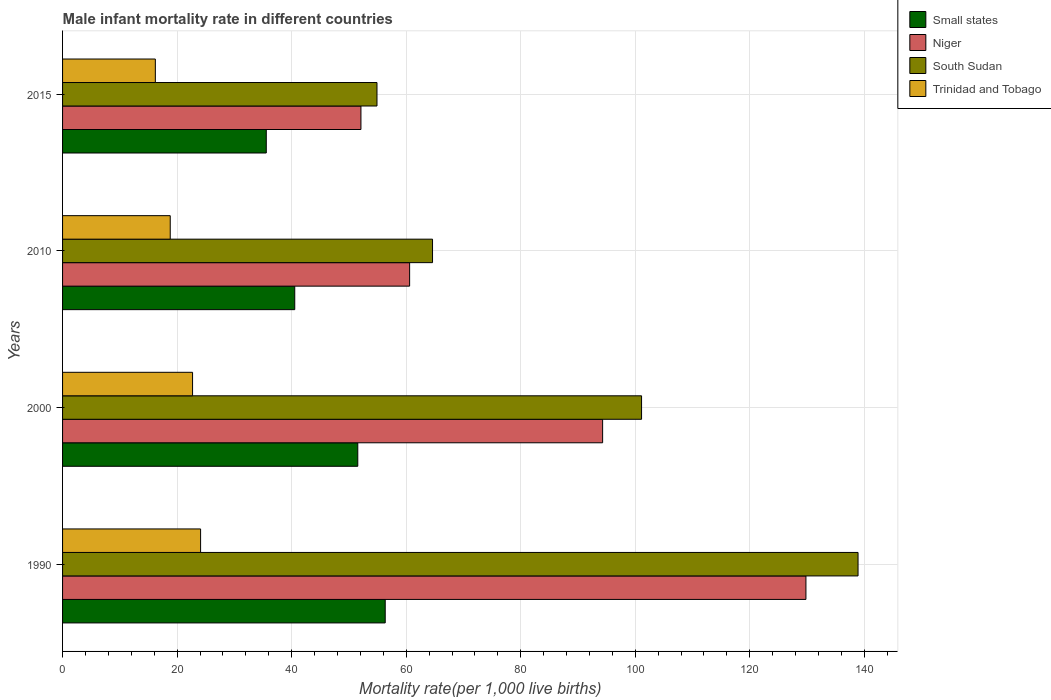How many different coloured bars are there?
Ensure brevity in your answer.  4. Are the number of bars on each tick of the Y-axis equal?
Provide a succinct answer. Yes. How many bars are there on the 4th tick from the top?
Your answer should be compact. 4. How many bars are there on the 2nd tick from the bottom?
Your response must be concise. 4. What is the label of the 2nd group of bars from the top?
Keep it short and to the point. 2010. What is the male infant mortality rate in Trinidad and Tobago in 2000?
Provide a succinct answer. 22.7. Across all years, what is the maximum male infant mortality rate in South Sudan?
Provide a succinct answer. 138.9. Across all years, what is the minimum male infant mortality rate in Small states?
Ensure brevity in your answer.  35.57. In which year was the male infant mortality rate in Niger minimum?
Provide a succinct answer. 2015. What is the total male infant mortality rate in Niger in the graph?
Offer a very short reply. 336.8. What is the difference between the male infant mortality rate in Small states in 1990 and that in 2000?
Your answer should be compact. 4.79. What is the difference between the male infant mortality rate in Small states in 2010 and the male infant mortality rate in Niger in 2015?
Provide a succinct answer. -11.56. What is the average male infant mortality rate in Trinidad and Tobago per year?
Your answer should be compact. 20.45. In the year 1990, what is the difference between the male infant mortality rate in Trinidad and Tobago and male infant mortality rate in Small states?
Offer a terse response. -32.24. What is the ratio of the male infant mortality rate in Trinidad and Tobago in 2000 to that in 2015?
Offer a very short reply. 1.4. What is the difference between the highest and the second highest male infant mortality rate in South Sudan?
Provide a succinct answer. 37.8. What is the difference between the highest and the lowest male infant mortality rate in Small states?
Give a very brief answer. 20.77. In how many years, is the male infant mortality rate in Niger greater than the average male infant mortality rate in Niger taken over all years?
Your answer should be very brief. 2. Is it the case that in every year, the sum of the male infant mortality rate in Small states and male infant mortality rate in Niger is greater than the sum of male infant mortality rate in Trinidad and Tobago and male infant mortality rate in South Sudan?
Provide a succinct answer. No. What does the 3rd bar from the top in 2010 represents?
Make the answer very short. Niger. What does the 1st bar from the bottom in 2015 represents?
Your response must be concise. Small states. Is it the case that in every year, the sum of the male infant mortality rate in Small states and male infant mortality rate in South Sudan is greater than the male infant mortality rate in Trinidad and Tobago?
Ensure brevity in your answer.  Yes. What is the difference between two consecutive major ticks on the X-axis?
Ensure brevity in your answer.  20. Are the values on the major ticks of X-axis written in scientific E-notation?
Provide a succinct answer. No. Does the graph contain any zero values?
Your answer should be very brief. No. How many legend labels are there?
Offer a terse response. 4. How are the legend labels stacked?
Ensure brevity in your answer.  Vertical. What is the title of the graph?
Ensure brevity in your answer.  Male infant mortality rate in different countries. Does "Liechtenstein" appear as one of the legend labels in the graph?
Ensure brevity in your answer.  No. What is the label or title of the X-axis?
Make the answer very short. Mortality rate(per 1,0 live births). What is the label or title of the Y-axis?
Provide a succinct answer. Years. What is the Mortality rate(per 1,000 live births) of Small states in 1990?
Provide a succinct answer. 56.34. What is the Mortality rate(per 1,000 live births) of Niger in 1990?
Provide a succinct answer. 129.8. What is the Mortality rate(per 1,000 live births) of South Sudan in 1990?
Provide a succinct answer. 138.9. What is the Mortality rate(per 1,000 live births) of Trinidad and Tobago in 1990?
Offer a very short reply. 24.1. What is the Mortality rate(per 1,000 live births) of Small states in 2000?
Keep it short and to the point. 51.55. What is the Mortality rate(per 1,000 live births) in Niger in 2000?
Keep it short and to the point. 94.3. What is the Mortality rate(per 1,000 live births) in South Sudan in 2000?
Keep it short and to the point. 101.1. What is the Mortality rate(per 1,000 live births) in Trinidad and Tobago in 2000?
Your answer should be very brief. 22.7. What is the Mortality rate(per 1,000 live births) of Small states in 2010?
Your answer should be compact. 40.54. What is the Mortality rate(per 1,000 live births) of Niger in 2010?
Your answer should be very brief. 60.6. What is the Mortality rate(per 1,000 live births) in South Sudan in 2010?
Offer a very short reply. 64.6. What is the Mortality rate(per 1,000 live births) of Trinidad and Tobago in 2010?
Your answer should be compact. 18.8. What is the Mortality rate(per 1,000 live births) of Small states in 2015?
Make the answer very short. 35.57. What is the Mortality rate(per 1,000 live births) of Niger in 2015?
Offer a terse response. 52.1. What is the Mortality rate(per 1,000 live births) of South Sudan in 2015?
Your response must be concise. 54.9. What is the Mortality rate(per 1,000 live births) of Trinidad and Tobago in 2015?
Provide a short and direct response. 16.2. Across all years, what is the maximum Mortality rate(per 1,000 live births) in Small states?
Provide a short and direct response. 56.34. Across all years, what is the maximum Mortality rate(per 1,000 live births) of Niger?
Your answer should be compact. 129.8. Across all years, what is the maximum Mortality rate(per 1,000 live births) in South Sudan?
Your answer should be compact. 138.9. Across all years, what is the maximum Mortality rate(per 1,000 live births) in Trinidad and Tobago?
Ensure brevity in your answer.  24.1. Across all years, what is the minimum Mortality rate(per 1,000 live births) of Small states?
Your response must be concise. 35.57. Across all years, what is the minimum Mortality rate(per 1,000 live births) of Niger?
Ensure brevity in your answer.  52.1. Across all years, what is the minimum Mortality rate(per 1,000 live births) in South Sudan?
Provide a succinct answer. 54.9. What is the total Mortality rate(per 1,000 live births) in Small states in the graph?
Offer a very short reply. 184. What is the total Mortality rate(per 1,000 live births) in Niger in the graph?
Ensure brevity in your answer.  336.8. What is the total Mortality rate(per 1,000 live births) of South Sudan in the graph?
Provide a succinct answer. 359.5. What is the total Mortality rate(per 1,000 live births) in Trinidad and Tobago in the graph?
Ensure brevity in your answer.  81.8. What is the difference between the Mortality rate(per 1,000 live births) of Small states in 1990 and that in 2000?
Provide a succinct answer. 4.79. What is the difference between the Mortality rate(per 1,000 live births) in Niger in 1990 and that in 2000?
Give a very brief answer. 35.5. What is the difference between the Mortality rate(per 1,000 live births) of South Sudan in 1990 and that in 2000?
Make the answer very short. 37.8. What is the difference between the Mortality rate(per 1,000 live births) in Small states in 1990 and that in 2010?
Offer a terse response. 15.8. What is the difference between the Mortality rate(per 1,000 live births) of Niger in 1990 and that in 2010?
Keep it short and to the point. 69.2. What is the difference between the Mortality rate(per 1,000 live births) in South Sudan in 1990 and that in 2010?
Give a very brief answer. 74.3. What is the difference between the Mortality rate(per 1,000 live births) in Trinidad and Tobago in 1990 and that in 2010?
Make the answer very short. 5.3. What is the difference between the Mortality rate(per 1,000 live births) in Small states in 1990 and that in 2015?
Ensure brevity in your answer.  20.77. What is the difference between the Mortality rate(per 1,000 live births) in Niger in 1990 and that in 2015?
Ensure brevity in your answer.  77.7. What is the difference between the Mortality rate(per 1,000 live births) of South Sudan in 1990 and that in 2015?
Your response must be concise. 84. What is the difference between the Mortality rate(per 1,000 live births) in Small states in 2000 and that in 2010?
Your answer should be compact. 11.01. What is the difference between the Mortality rate(per 1,000 live births) in Niger in 2000 and that in 2010?
Your response must be concise. 33.7. What is the difference between the Mortality rate(per 1,000 live births) of South Sudan in 2000 and that in 2010?
Offer a very short reply. 36.5. What is the difference between the Mortality rate(per 1,000 live births) of Small states in 2000 and that in 2015?
Provide a succinct answer. 15.98. What is the difference between the Mortality rate(per 1,000 live births) in Niger in 2000 and that in 2015?
Provide a succinct answer. 42.2. What is the difference between the Mortality rate(per 1,000 live births) in South Sudan in 2000 and that in 2015?
Give a very brief answer. 46.2. What is the difference between the Mortality rate(per 1,000 live births) of Trinidad and Tobago in 2000 and that in 2015?
Your answer should be very brief. 6.5. What is the difference between the Mortality rate(per 1,000 live births) in Small states in 2010 and that in 2015?
Keep it short and to the point. 4.97. What is the difference between the Mortality rate(per 1,000 live births) of Trinidad and Tobago in 2010 and that in 2015?
Keep it short and to the point. 2.6. What is the difference between the Mortality rate(per 1,000 live births) of Small states in 1990 and the Mortality rate(per 1,000 live births) of Niger in 2000?
Give a very brief answer. -37.96. What is the difference between the Mortality rate(per 1,000 live births) of Small states in 1990 and the Mortality rate(per 1,000 live births) of South Sudan in 2000?
Offer a very short reply. -44.76. What is the difference between the Mortality rate(per 1,000 live births) of Small states in 1990 and the Mortality rate(per 1,000 live births) of Trinidad and Tobago in 2000?
Ensure brevity in your answer.  33.64. What is the difference between the Mortality rate(per 1,000 live births) in Niger in 1990 and the Mortality rate(per 1,000 live births) in South Sudan in 2000?
Provide a succinct answer. 28.7. What is the difference between the Mortality rate(per 1,000 live births) in Niger in 1990 and the Mortality rate(per 1,000 live births) in Trinidad and Tobago in 2000?
Your answer should be compact. 107.1. What is the difference between the Mortality rate(per 1,000 live births) of South Sudan in 1990 and the Mortality rate(per 1,000 live births) of Trinidad and Tobago in 2000?
Make the answer very short. 116.2. What is the difference between the Mortality rate(per 1,000 live births) in Small states in 1990 and the Mortality rate(per 1,000 live births) in Niger in 2010?
Offer a terse response. -4.26. What is the difference between the Mortality rate(per 1,000 live births) in Small states in 1990 and the Mortality rate(per 1,000 live births) in South Sudan in 2010?
Provide a short and direct response. -8.26. What is the difference between the Mortality rate(per 1,000 live births) in Small states in 1990 and the Mortality rate(per 1,000 live births) in Trinidad and Tobago in 2010?
Your answer should be compact. 37.54. What is the difference between the Mortality rate(per 1,000 live births) in Niger in 1990 and the Mortality rate(per 1,000 live births) in South Sudan in 2010?
Your answer should be compact. 65.2. What is the difference between the Mortality rate(per 1,000 live births) of Niger in 1990 and the Mortality rate(per 1,000 live births) of Trinidad and Tobago in 2010?
Your answer should be very brief. 111. What is the difference between the Mortality rate(per 1,000 live births) of South Sudan in 1990 and the Mortality rate(per 1,000 live births) of Trinidad and Tobago in 2010?
Your answer should be very brief. 120.1. What is the difference between the Mortality rate(per 1,000 live births) in Small states in 1990 and the Mortality rate(per 1,000 live births) in Niger in 2015?
Provide a short and direct response. 4.24. What is the difference between the Mortality rate(per 1,000 live births) in Small states in 1990 and the Mortality rate(per 1,000 live births) in South Sudan in 2015?
Your response must be concise. 1.44. What is the difference between the Mortality rate(per 1,000 live births) in Small states in 1990 and the Mortality rate(per 1,000 live births) in Trinidad and Tobago in 2015?
Provide a succinct answer. 40.14. What is the difference between the Mortality rate(per 1,000 live births) in Niger in 1990 and the Mortality rate(per 1,000 live births) in South Sudan in 2015?
Provide a succinct answer. 74.9. What is the difference between the Mortality rate(per 1,000 live births) of Niger in 1990 and the Mortality rate(per 1,000 live births) of Trinidad and Tobago in 2015?
Provide a succinct answer. 113.6. What is the difference between the Mortality rate(per 1,000 live births) in South Sudan in 1990 and the Mortality rate(per 1,000 live births) in Trinidad and Tobago in 2015?
Your response must be concise. 122.7. What is the difference between the Mortality rate(per 1,000 live births) of Small states in 2000 and the Mortality rate(per 1,000 live births) of Niger in 2010?
Offer a very short reply. -9.05. What is the difference between the Mortality rate(per 1,000 live births) in Small states in 2000 and the Mortality rate(per 1,000 live births) in South Sudan in 2010?
Provide a succinct answer. -13.05. What is the difference between the Mortality rate(per 1,000 live births) in Small states in 2000 and the Mortality rate(per 1,000 live births) in Trinidad and Tobago in 2010?
Keep it short and to the point. 32.75. What is the difference between the Mortality rate(per 1,000 live births) in Niger in 2000 and the Mortality rate(per 1,000 live births) in South Sudan in 2010?
Offer a very short reply. 29.7. What is the difference between the Mortality rate(per 1,000 live births) in Niger in 2000 and the Mortality rate(per 1,000 live births) in Trinidad and Tobago in 2010?
Your answer should be compact. 75.5. What is the difference between the Mortality rate(per 1,000 live births) of South Sudan in 2000 and the Mortality rate(per 1,000 live births) of Trinidad and Tobago in 2010?
Provide a succinct answer. 82.3. What is the difference between the Mortality rate(per 1,000 live births) of Small states in 2000 and the Mortality rate(per 1,000 live births) of Niger in 2015?
Offer a very short reply. -0.55. What is the difference between the Mortality rate(per 1,000 live births) in Small states in 2000 and the Mortality rate(per 1,000 live births) in South Sudan in 2015?
Provide a short and direct response. -3.35. What is the difference between the Mortality rate(per 1,000 live births) of Small states in 2000 and the Mortality rate(per 1,000 live births) of Trinidad and Tobago in 2015?
Your answer should be very brief. 35.35. What is the difference between the Mortality rate(per 1,000 live births) in Niger in 2000 and the Mortality rate(per 1,000 live births) in South Sudan in 2015?
Make the answer very short. 39.4. What is the difference between the Mortality rate(per 1,000 live births) of Niger in 2000 and the Mortality rate(per 1,000 live births) of Trinidad and Tobago in 2015?
Offer a terse response. 78.1. What is the difference between the Mortality rate(per 1,000 live births) of South Sudan in 2000 and the Mortality rate(per 1,000 live births) of Trinidad and Tobago in 2015?
Your response must be concise. 84.9. What is the difference between the Mortality rate(per 1,000 live births) in Small states in 2010 and the Mortality rate(per 1,000 live births) in Niger in 2015?
Keep it short and to the point. -11.56. What is the difference between the Mortality rate(per 1,000 live births) of Small states in 2010 and the Mortality rate(per 1,000 live births) of South Sudan in 2015?
Offer a very short reply. -14.36. What is the difference between the Mortality rate(per 1,000 live births) in Small states in 2010 and the Mortality rate(per 1,000 live births) in Trinidad and Tobago in 2015?
Ensure brevity in your answer.  24.34. What is the difference between the Mortality rate(per 1,000 live births) in Niger in 2010 and the Mortality rate(per 1,000 live births) in South Sudan in 2015?
Provide a succinct answer. 5.7. What is the difference between the Mortality rate(per 1,000 live births) of Niger in 2010 and the Mortality rate(per 1,000 live births) of Trinidad and Tobago in 2015?
Your response must be concise. 44.4. What is the difference between the Mortality rate(per 1,000 live births) in South Sudan in 2010 and the Mortality rate(per 1,000 live births) in Trinidad and Tobago in 2015?
Provide a succinct answer. 48.4. What is the average Mortality rate(per 1,000 live births) in Small states per year?
Your answer should be compact. 46. What is the average Mortality rate(per 1,000 live births) of Niger per year?
Make the answer very short. 84.2. What is the average Mortality rate(per 1,000 live births) of South Sudan per year?
Offer a very short reply. 89.88. What is the average Mortality rate(per 1,000 live births) of Trinidad and Tobago per year?
Provide a succinct answer. 20.45. In the year 1990, what is the difference between the Mortality rate(per 1,000 live births) in Small states and Mortality rate(per 1,000 live births) in Niger?
Provide a short and direct response. -73.46. In the year 1990, what is the difference between the Mortality rate(per 1,000 live births) of Small states and Mortality rate(per 1,000 live births) of South Sudan?
Provide a short and direct response. -82.56. In the year 1990, what is the difference between the Mortality rate(per 1,000 live births) of Small states and Mortality rate(per 1,000 live births) of Trinidad and Tobago?
Provide a succinct answer. 32.24. In the year 1990, what is the difference between the Mortality rate(per 1,000 live births) of Niger and Mortality rate(per 1,000 live births) of Trinidad and Tobago?
Keep it short and to the point. 105.7. In the year 1990, what is the difference between the Mortality rate(per 1,000 live births) in South Sudan and Mortality rate(per 1,000 live births) in Trinidad and Tobago?
Make the answer very short. 114.8. In the year 2000, what is the difference between the Mortality rate(per 1,000 live births) of Small states and Mortality rate(per 1,000 live births) of Niger?
Ensure brevity in your answer.  -42.75. In the year 2000, what is the difference between the Mortality rate(per 1,000 live births) of Small states and Mortality rate(per 1,000 live births) of South Sudan?
Give a very brief answer. -49.55. In the year 2000, what is the difference between the Mortality rate(per 1,000 live births) in Small states and Mortality rate(per 1,000 live births) in Trinidad and Tobago?
Your answer should be very brief. 28.85. In the year 2000, what is the difference between the Mortality rate(per 1,000 live births) of Niger and Mortality rate(per 1,000 live births) of South Sudan?
Your answer should be compact. -6.8. In the year 2000, what is the difference between the Mortality rate(per 1,000 live births) of Niger and Mortality rate(per 1,000 live births) of Trinidad and Tobago?
Your answer should be very brief. 71.6. In the year 2000, what is the difference between the Mortality rate(per 1,000 live births) of South Sudan and Mortality rate(per 1,000 live births) of Trinidad and Tobago?
Ensure brevity in your answer.  78.4. In the year 2010, what is the difference between the Mortality rate(per 1,000 live births) in Small states and Mortality rate(per 1,000 live births) in Niger?
Your answer should be very brief. -20.06. In the year 2010, what is the difference between the Mortality rate(per 1,000 live births) in Small states and Mortality rate(per 1,000 live births) in South Sudan?
Offer a terse response. -24.06. In the year 2010, what is the difference between the Mortality rate(per 1,000 live births) in Small states and Mortality rate(per 1,000 live births) in Trinidad and Tobago?
Offer a terse response. 21.74. In the year 2010, what is the difference between the Mortality rate(per 1,000 live births) in Niger and Mortality rate(per 1,000 live births) in Trinidad and Tobago?
Ensure brevity in your answer.  41.8. In the year 2010, what is the difference between the Mortality rate(per 1,000 live births) of South Sudan and Mortality rate(per 1,000 live births) of Trinidad and Tobago?
Offer a very short reply. 45.8. In the year 2015, what is the difference between the Mortality rate(per 1,000 live births) in Small states and Mortality rate(per 1,000 live births) in Niger?
Provide a succinct answer. -16.53. In the year 2015, what is the difference between the Mortality rate(per 1,000 live births) of Small states and Mortality rate(per 1,000 live births) of South Sudan?
Make the answer very short. -19.33. In the year 2015, what is the difference between the Mortality rate(per 1,000 live births) in Small states and Mortality rate(per 1,000 live births) in Trinidad and Tobago?
Make the answer very short. 19.37. In the year 2015, what is the difference between the Mortality rate(per 1,000 live births) of Niger and Mortality rate(per 1,000 live births) of Trinidad and Tobago?
Your response must be concise. 35.9. In the year 2015, what is the difference between the Mortality rate(per 1,000 live births) in South Sudan and Mortality rate(per 1,000 live births) in Trinidad and Tobago?
Provide a short and direct response. 38.7. What is the ratio of the Mortality rate(per 1,000 live births) of Small states in 1990 to that in 2000?
Ensure brevity in your answer.  1.09. What is the ratio of the Mortality rate(per 1,000 live births) of Niger in 1990 to that in 2000?
Offer a very short reply. 1.38. What is the ratio of the Mortality rate(per 1,000 live births) in South Sudan in 1990 to that in 2000?
Give a very brief answer. 1.37. What is the ratio of the Mortality rate(per 1,000 live births) of Trinidad and Tobago in 1990 to that in 2000?
Your answer should be compact. 1.06. What is the ratio of the Mortality rate(per 1,000 live births) in Small states in 1990 to that in 2010?
Ensure brevity in your answer.  1.39. What is the ratio of the Mortality rate(per 1,000 live births) in Niger in 1990 to that in 2010?
Offer a very short reply. 2.14. What is the ratio of the Mortality rate(per 1,000 live births) in South Sudan in 1990 to that in 2010?
Offer a very short reply. 2.15. What is the ratio of the Mortality rate(per 1,000 live births) in Trinidad and Tobago in 1990 to that in 2010?
Make the answer very short. 1.28. What is the ratio of the Mortality rate(per 1,000 live births) in Small states in 1990 to that in 2015?
Ensure brevity in your answer.  1.58. What is the ratio of the Mortality rate(per 1,000 live births) of Niger in 1990 to that in 2015?
Your answer should be compact. 2.49. What is the ratio of the Mortality rate(per 1,000 live births) of South Sudan in 1990 to that in 2015?
Provide a succinct answer. 2.53. What is the ratio of the Mortality rate(per 1,000 live births) in Trinidad and Tobago in 1990 to that in 2015?
Make the answer very short. 1.49. What is the ratio of the Mortality rate(per 1,000 live births) in Small states in 2000 to that in 2010?
Make the answer very short. 1.27. What is the ratio of the Mortality rate(per 1,000 live births) of Niger in 2000 to that in 2010?
Your answer should be very brief. 1.56. What is the ratio of the Mortality rate(per 1,000 live births) of South Sudan in 2000 to that in 2010?
Provide a succinct answer. 1.56. What is the ratio of the Mortality rate(per 1,000 live births) in Trinidad and Tobago in 2000 to that in 2010?
Offer a terse response. 1.21. What is the ratio of the Mortality rate(per 1,000 live births) in Small states in 2000 to that in 2015?
Offer a terse response. 1.45. What is the ratio of the Mortality rate(per 1,000 live births) of Niger in 2000 to that in 2015?
Offer a very short reply. 1.81. What is the ratio of the Mortality rate(per 1,000 live births) of South Sudan in 2000 to that in 2015?
Give a very brief answer. 1.84. What is the ratio of the Mortality rate(per 1,000 live births) in Trinidad and Tobago in 2000 to that in 2015?
Offer a terse response. 1.4. What is the ratio of the Mortality rate(per 1,000 live births) in Small states in 2010 to that in 2015?
Keep it short and to the point. 1.14. What is the ratio of the Mortality rate(per 1,000 live births) of Niger in 2010 to that in 2015?
Offer a terse response. 1.16. What is the ratio of the Mortality rate(per 1,000 live births) of South Sudan in 2010 to that in 2015?
Offer a terse response. 1.18. What is the ratio of the Mortality rate(per 1,000 live births) in Trinidad and Tobago in 2010 to that in 2015?
Ensure brevity in your answer.  1.16. What is the difference between the highest and the second highest Mortality rate(per 1,000 live births) of Small states?
Ensure brevity in your answer.  4.79. What is the difference between the highest and the second highest Mortality rate(per 1,000 live births) in Niger?
Provide a succinct answer. 35.5. What is the difference between the highest and the second highest Mortality rate(per 1,000 live births) in South Sudan?
Provide a succinct answer. 37.8. What is the difference between the highest and the lowest Mortality rate(per 1,000 live births) of Small states?
Your answer should be compact. 20.77. What is the difference between the highest and the lowest Mortality rate(per 1,000 live births) of Niger?
Ensure brevity in your answer.  77.7. What is the difference between the highest and the lowest Mortality rate(per 1,000 live births) in South Sudan?
Offer a terse response. 84. 